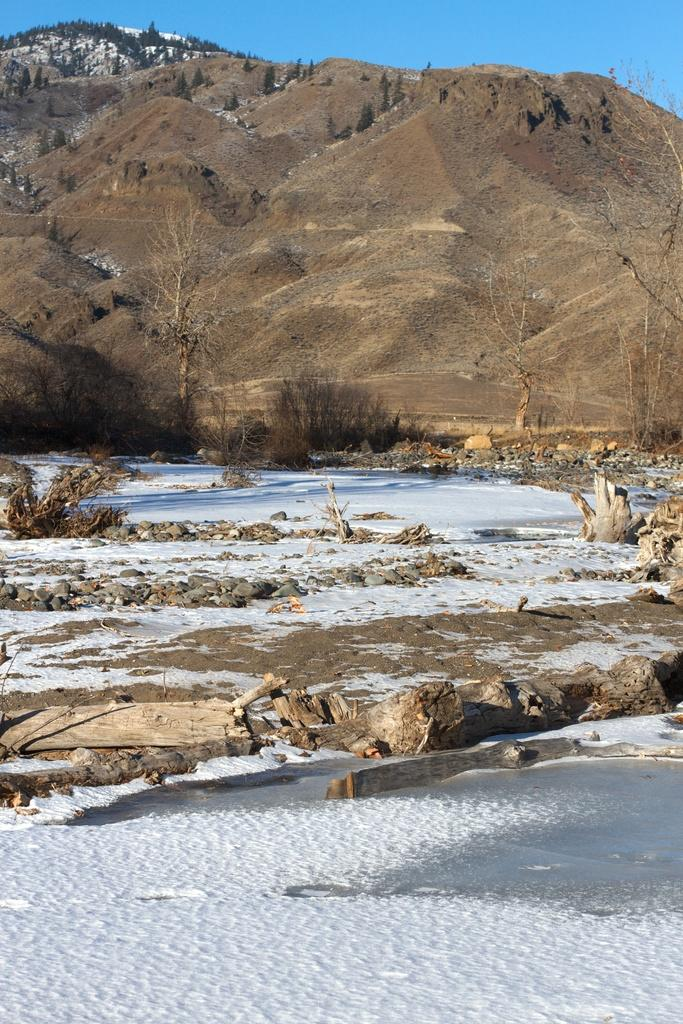What is the main object in the image? There is a rock in the image. What other natural elements can be seen in the image? There are trees, stones, and snow visible in the image. What part of the sky is visible in the image? The sky is visible in the image. What might be the texture of the barks in the image? The barks in the image might have a rough texture, similar to tree bark. What type of exchange is taking place between the rock and the trees in the image? There is no exchange taking place between the rock and the trees in the image; they are separate objects in the scene. 